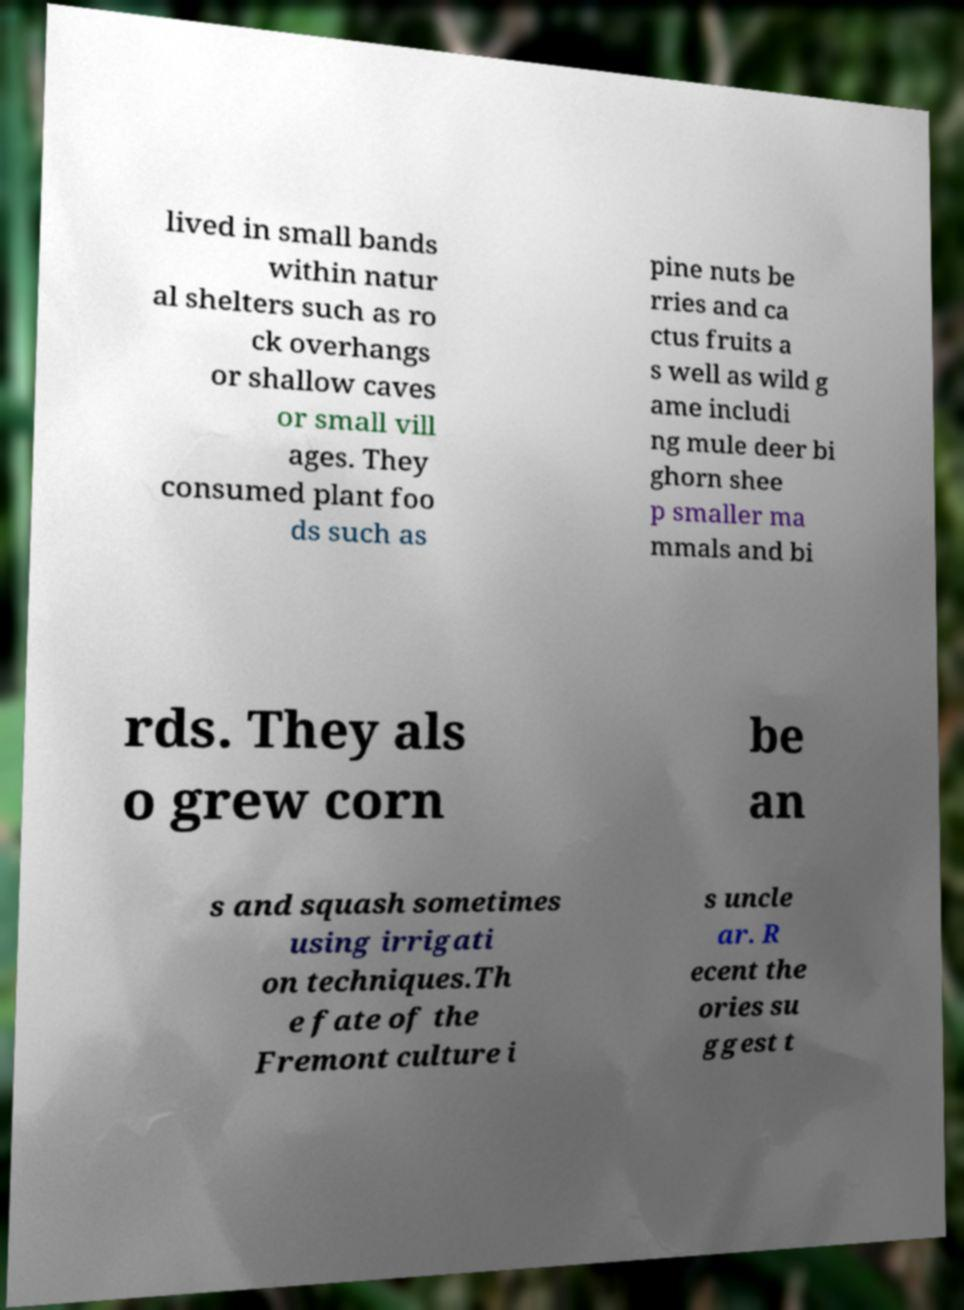Could you assist in decoding the text presented in this image and type it out clearly? lived in small bands within natur al shelters such as ro ck overhangs or shallow caves or small vill ages. They consumed plant foo ds such as pine nuts be rries and ca ctus fruits a s well as wild g ame includi ng mule deer bi ghorn shee p smaller ma mmals and bi rds. They als o grew corn be an s and squash sometimes using irrigati on techniques.Th e fate of the Fremont culture i s uncle ar. R ecent the ories su ggest t 